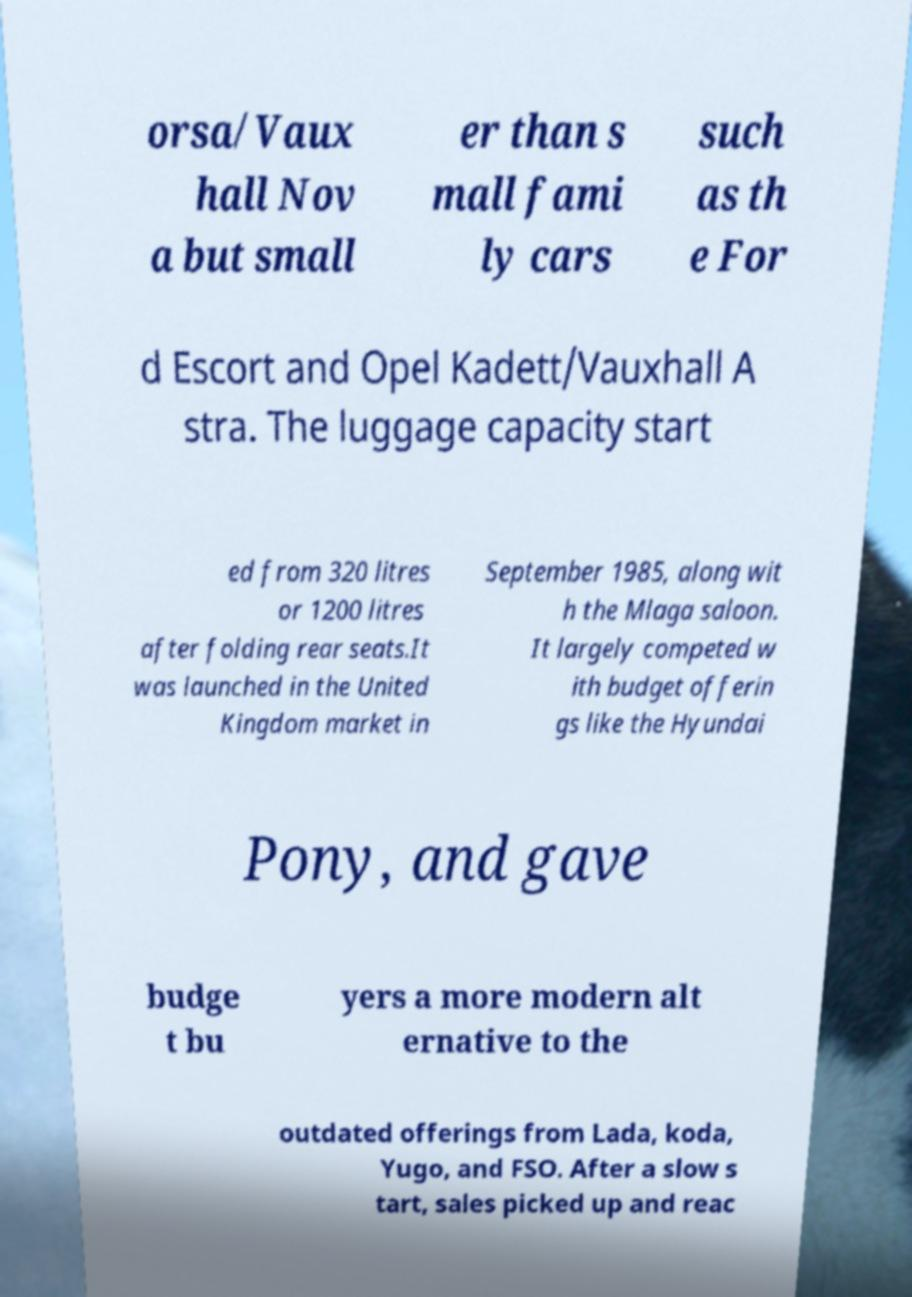Please identify and transcribe the text found in this image. orsa/Vaux hall Nov a but small er than s mall fami ly cars such as th e For d Escort and Opel Kadett/Vauxhall A stra. The luggage capacity start ed from 320 litres or 1200 litres after folding rear seats.It was launched in the United Kingdom market in September 1985, along wit h the Mlaga saloon. It largely competed w ith budget offerin gs like the Hyundai Pony, and gave budge t bu yers a more modern alt ernative to the outdated offerings from Lada, koda, Yugo, and FSO. After a slow s tart, sales picked up and reac 